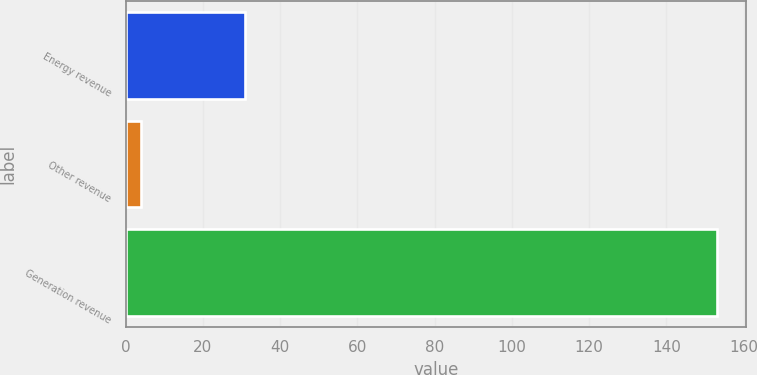Convert chart to OTSL. <chart><loc_0><loc_0><loc_500><loc_500><bar_chart><fcel>Energy revenue<fcel>Other revenue<fcel>Generation revenue<nl><fcel>31<fcel>4<fcel>153<nl></chart> 